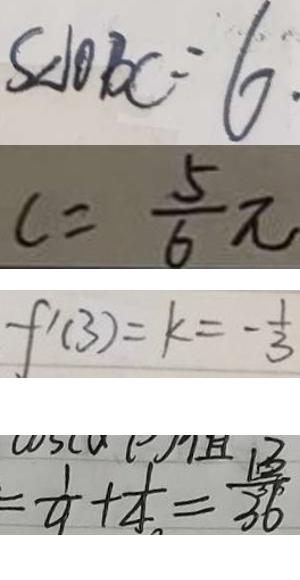<formula> <loc_0><loc_0><loc_500><loc_500>S _ { \Delta 1 0 B C } = 6 . 
 c = \frac { 5 } { 6 } \pi 
 f ^ { \prime } ( 3 ) = k = - \frac { 1 } { 3 } 
 = \frac { 1 } { 9 } + \frac { 1 } { 4 } = \frac { 1 3 } { 3 6 }</formula> 